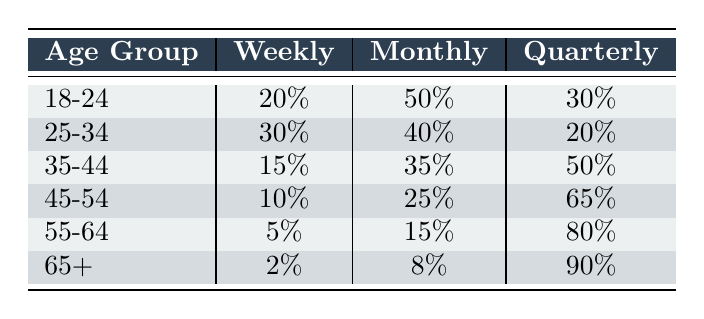What percentage of the 18-24 age group makes weekly purchases? The table lists the percentage for the 18-24 age group under the "Weekly" column, which shows 20%.
Answer: 20% Which age group has the highest percentage of quarterly purchases? By examining the "Quarterly" column, the 65+ age group has the highest percentage at 90%.
Answer: 65+ What is the total percentage of monthly purchases for the age group 25-34 and 35-44 combined? First, find the monthly purchase percentages: 25-34 has 40% and 35-44 has 35%. Adding these together gives 40% + 35% = 75%.
Answer: 75% Is it true that more than half of the 35-44 age group makes purchases quarterly? The table shows that 50% of the 35-44 age group makes quarterly purchases, which is not more than half.
Answer: No Which age group has the lowest percentage of both weekly and monthly purchases? Looking at the "Weekly" and "Monthly" columns, the 65+ age group has 2% and 8%, respectively. These are the lowest values for both categories.
Answer: 65+ What is the difference in percentage of weekly purchases between the 25-34 and 45-54 age groups? The weekly purchase percentage for the 25-34 age group is 30% and for the 45-54 age group is 10%. The difference is 30% - 10% = 20%.
Answer: 20% What is the average percentage of quarterly purchases across all age groups? To find the average, add all quarterly percentages (30 + 20 + 50 + 65 + 80 + 90 = 335) and divide by the number of age groups (6). So, 335 / 6 = 55.83%.
Answer: 55.83% Which age group has a higher percentage of monthly purchases, 45-54 or 55-64? The monthly purchases for the 45-54 age group are 25%, and for the 55-64 age group are 15%. Comparing these shows that 45-54 is higher.
Answer: Yes What is the total overall percentage of weekly purchases from all age groups? Sum all weekly percentages (20 + 30 + 15 + 10 + 5 + 2 = 82). Therefore, the total percentage of weekly purchases is 82%.
Answer: 82% 